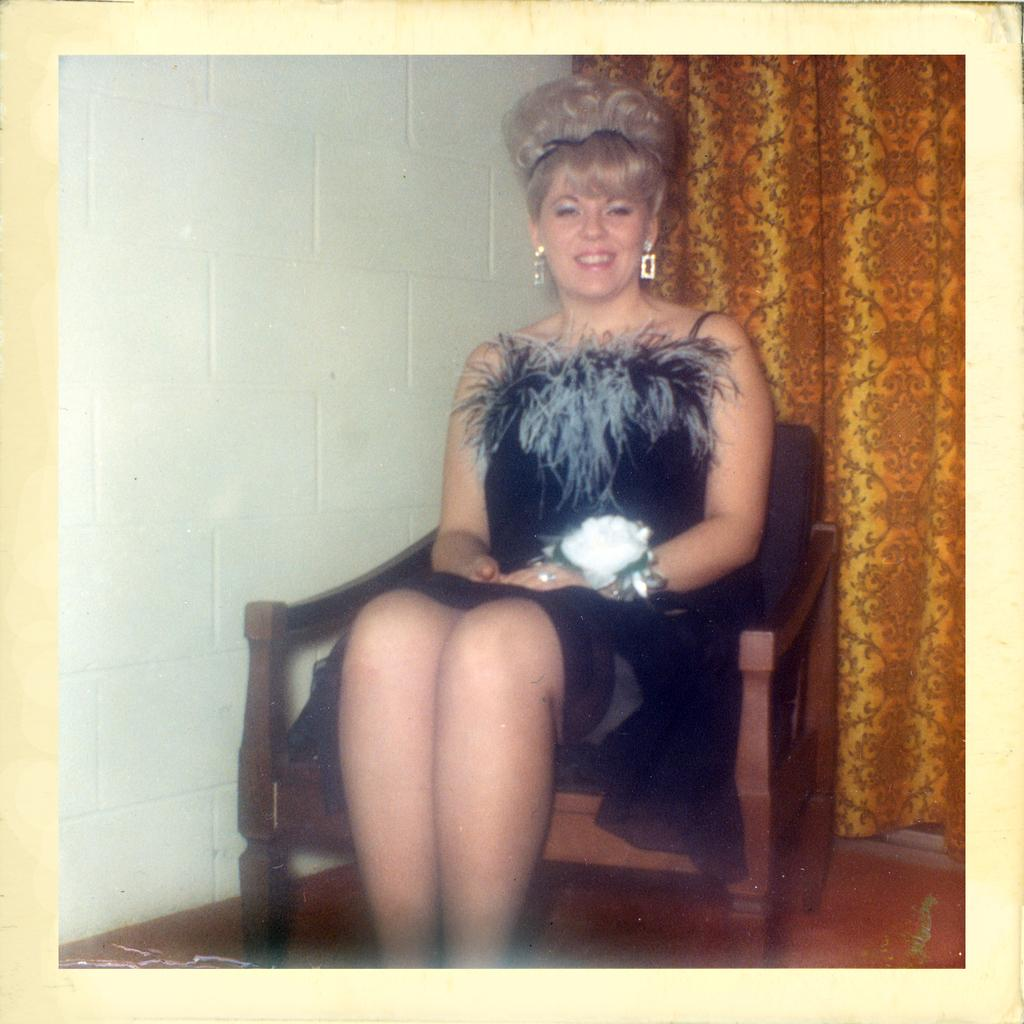Who is the main subject in the image? There is a lady in the image. What is the lady doing in the image? The lady is sitting on a chair. What is the lady wearing in the image? The lady is wearing an artificial flower. What can be seen in the background of the image? There is a curtain and a wall visible in the background of the image. What type of rod is the lady using to manage her debt in the image? There is no rod or mention of debt in the image; it features a lady sitting on a chair and wearing an artificial flower. 